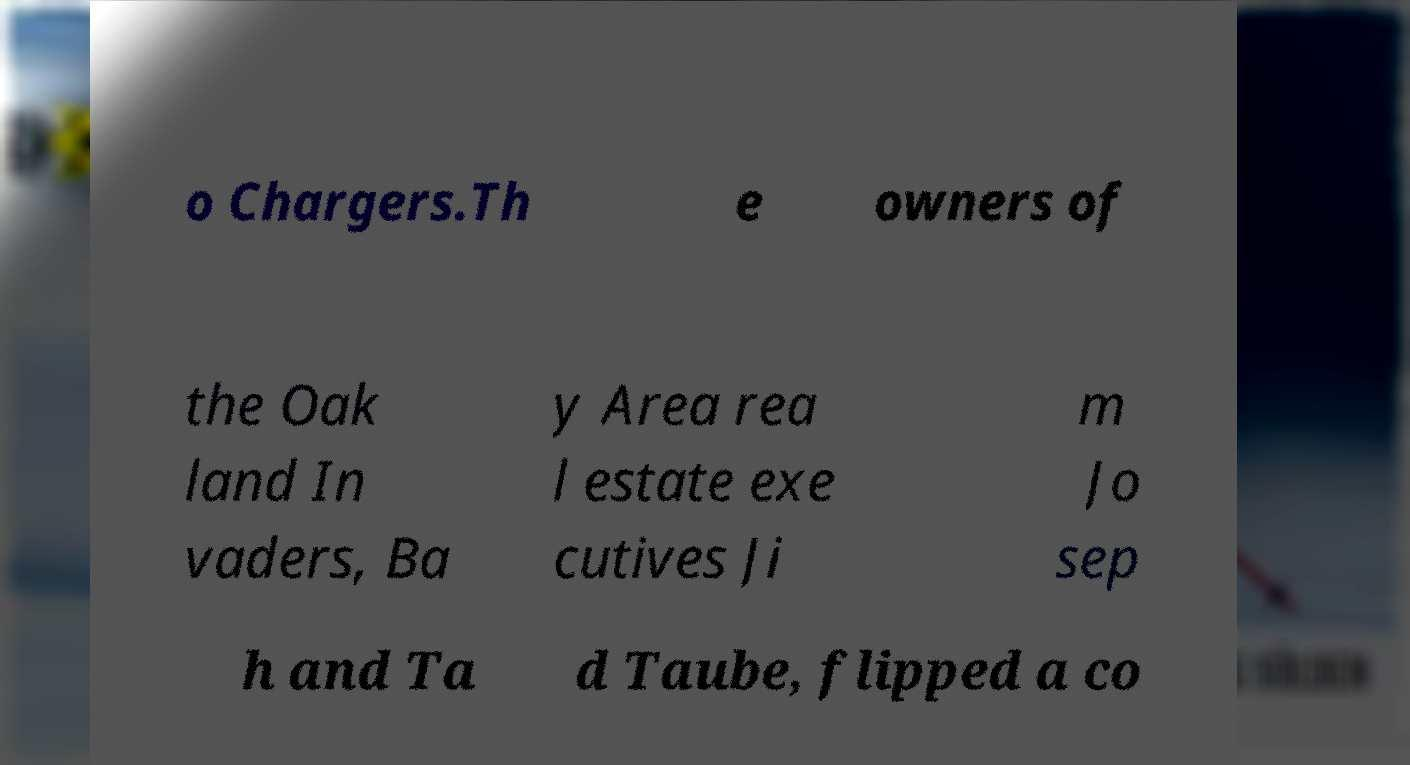Please identify and transcribe the text found in this image. o Chargers.Th e owners of the Oak land In vaders, Ba y Area rea l estate exe cutives Ji m Jo sep h and Ta d Taube, flipped a co 